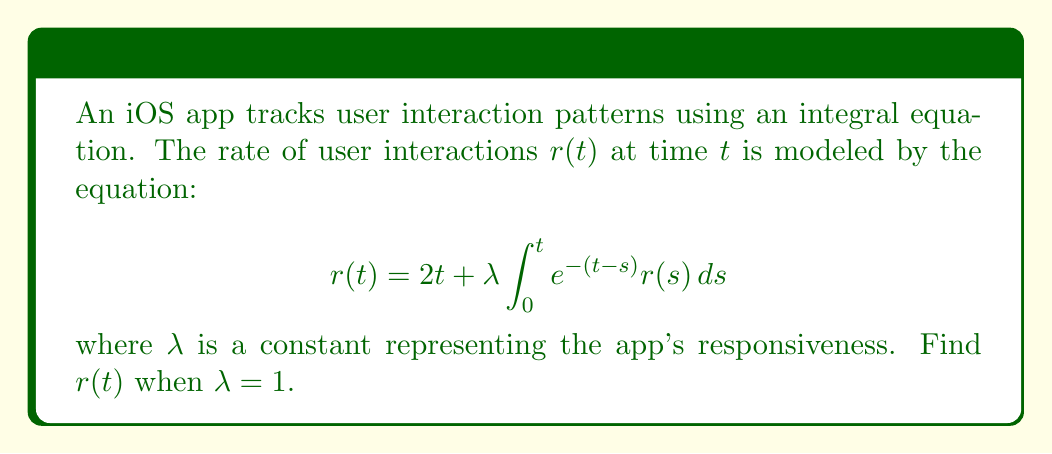Teach me how to tackle this problem. To solve this integral equation, we'll follow these steps:

1) First, we differentiate both sides of the equation with respect to $t$:

   $$\frac{d}{dt}r(t) = 2 + \lambda e^{-t} r(t) + \lambda \int_0^t (-e^{-(t-s)}) r(s) ds$$

2) Simplify using the original equation:

   $$\frac{d}{dt}r(t) = 2 + r(t) - 2t$$

3) Rearrange to get a standard form differential equation:

   $$\frac{d}{dt}r(t) - r(t) = -2t + 2$$

4) This is a first-order linear differential equation. The integrating factor is $e^{-t}$.

5) Multiply both sides by $e^{-t}$:

   $$e^{-t}\frac{d}{dt}r(t) - e^{-t}r(t) = -2te^{-t} + 2e^{-t}$$

6) The left side is now the derivative of $e^{-t}r(t)$. Integrate both sides:

   $$e^{-t}r(t) = \int (-2te^{-t} + 2e^{-t}) dt$$

7) Integrate the right side:

   $$e^{-t}r(t) = 2te^{-t} - 2e^{-t} + C$$

8) Solve for $r(t)$:

   $$r(t) = 2t - 2 + Ce^t$$

9) Use the initial condition $r(0) = 0$ to find $C$:

   $$0 = -2 + C$$
   $$C = 2$$

10) Therefore, the final solution is:

    $$r(t) = 2t - 2 + 2e^t$$
Answer: $r(t) = 2t - 2 + 2e^t$ 